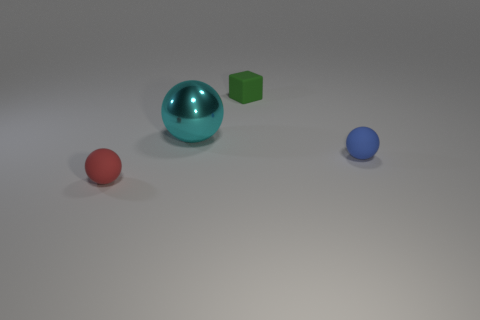Subtract all small spheres. How many spheres are left? 1 Subtract 0 red blocks. How many objects are left? 4 Subtract all cubes. How many objects are left? 3 Subtract 2 spheres. How many spheres are left? 1 Subtract all blue balls. Subtract all red cylinders. How many balls are left? 2 Subtract all blue cylinders. How many cyan blocks are left? 0 Subtract all large cyan things. Subtract all big metallic objects. How many objects are left? 2 Add 2 tiny blue rubber things. How many tiny blue rubber things are left? 3 Add 2 big cyan metallic objects. How many big cyan metallic objects exist? 3 Add 3 spheres. How many objects exist? 7 